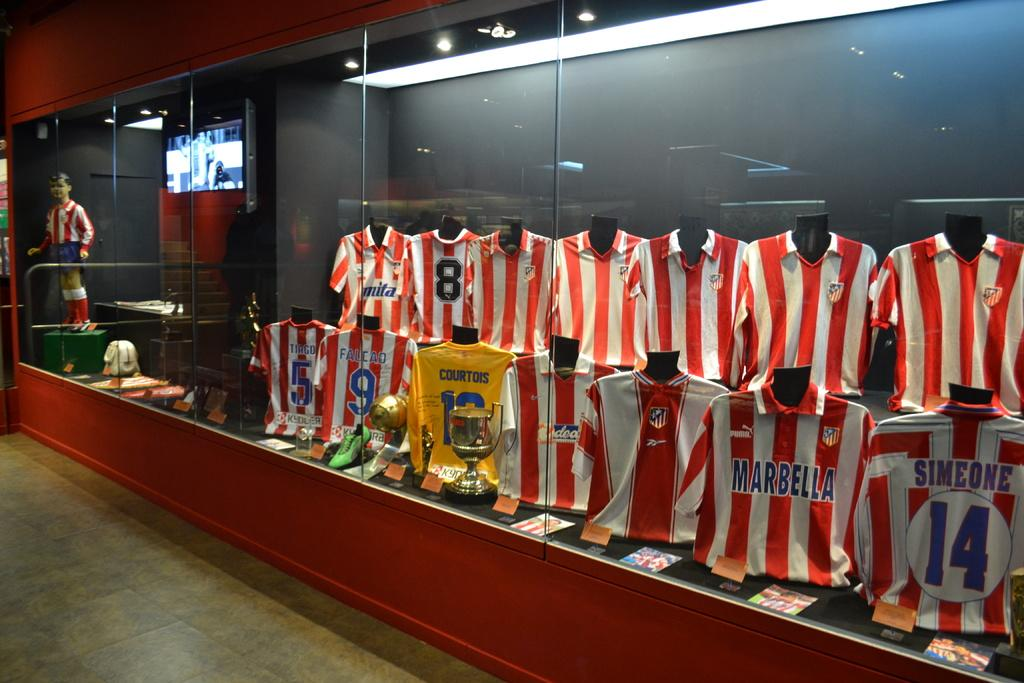<image>
Share a concise interpretation of the image provided. A class display case has several red and white striped jerseys and a single yellow one that says Courtois. 